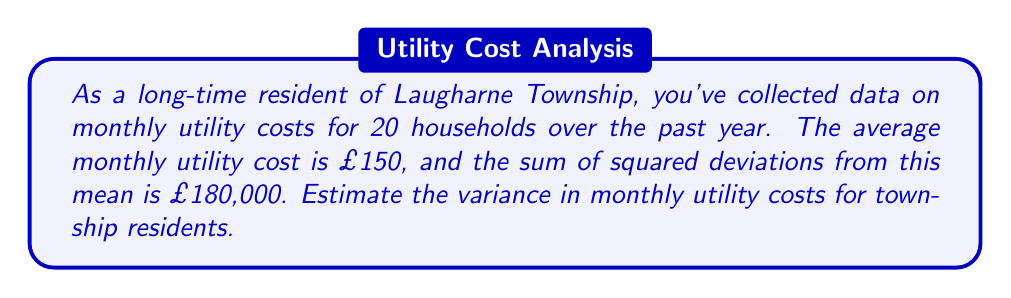What is the answer to this math problem? Let's approach this step-by-step:

1) The variance is defined as the average of squared deviations from the mean. Its formula is:

   $$\sigma^2 = \frac{\sum_{i=1}^{n} (x_i - \mu)^2}{n}$$

   where $\sigma^2$ is the variance, $x_i$ are the individual values, $\mu$ is the mean, and $n$ is the number of values.

2) We're given:
   - Number of households (sample size): $n = 20$
   - Mean monthly utility cost: $\mu = £150$
   - Sum of squared deviations: $\sum_{i=1}^{n} (x_i - \mu)^2 = £180,000$

3) We can directly substitute these values into the variance formula:

   $$\sigma^2 = \frac{£180,000}{20}$$

4) Simplifying:

   $$\sigma^2 = £9,000$$

Therefore, the estimated variance in monthly utility costs for township residents is £9,000.
Answer: £9,000 